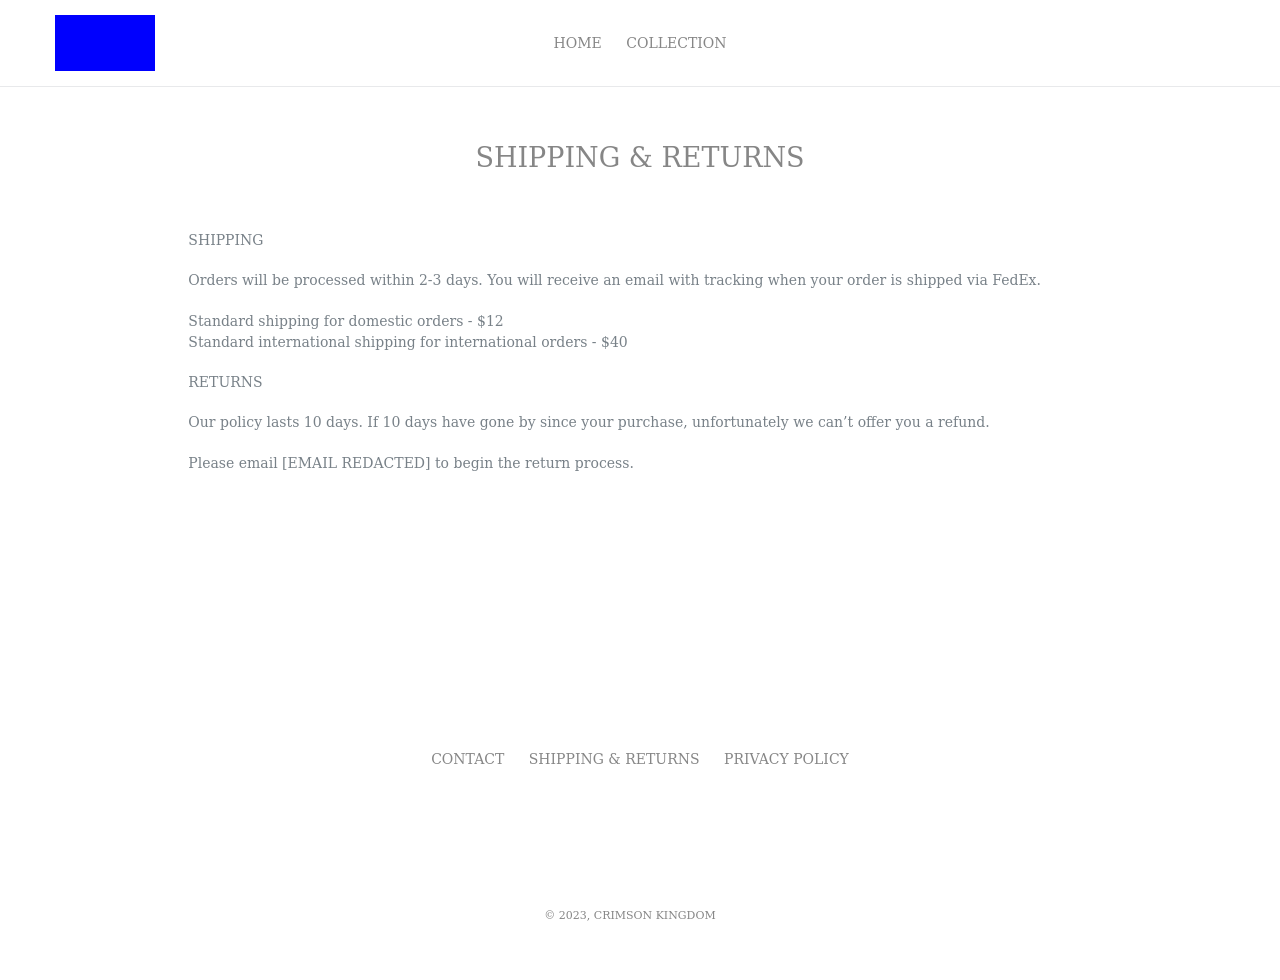Is there a way to make the shipping options more interactive on this webpage? Absolutely! You could enhance interactivity by using JavaScript to allow users to choose shipping options dynamically. For example, adding drop-down menus for different shipping types with costs updating based on selection. Additionally, integrating AJAX could allow the page to update these elements without the need to reload, enhancing user experience. 